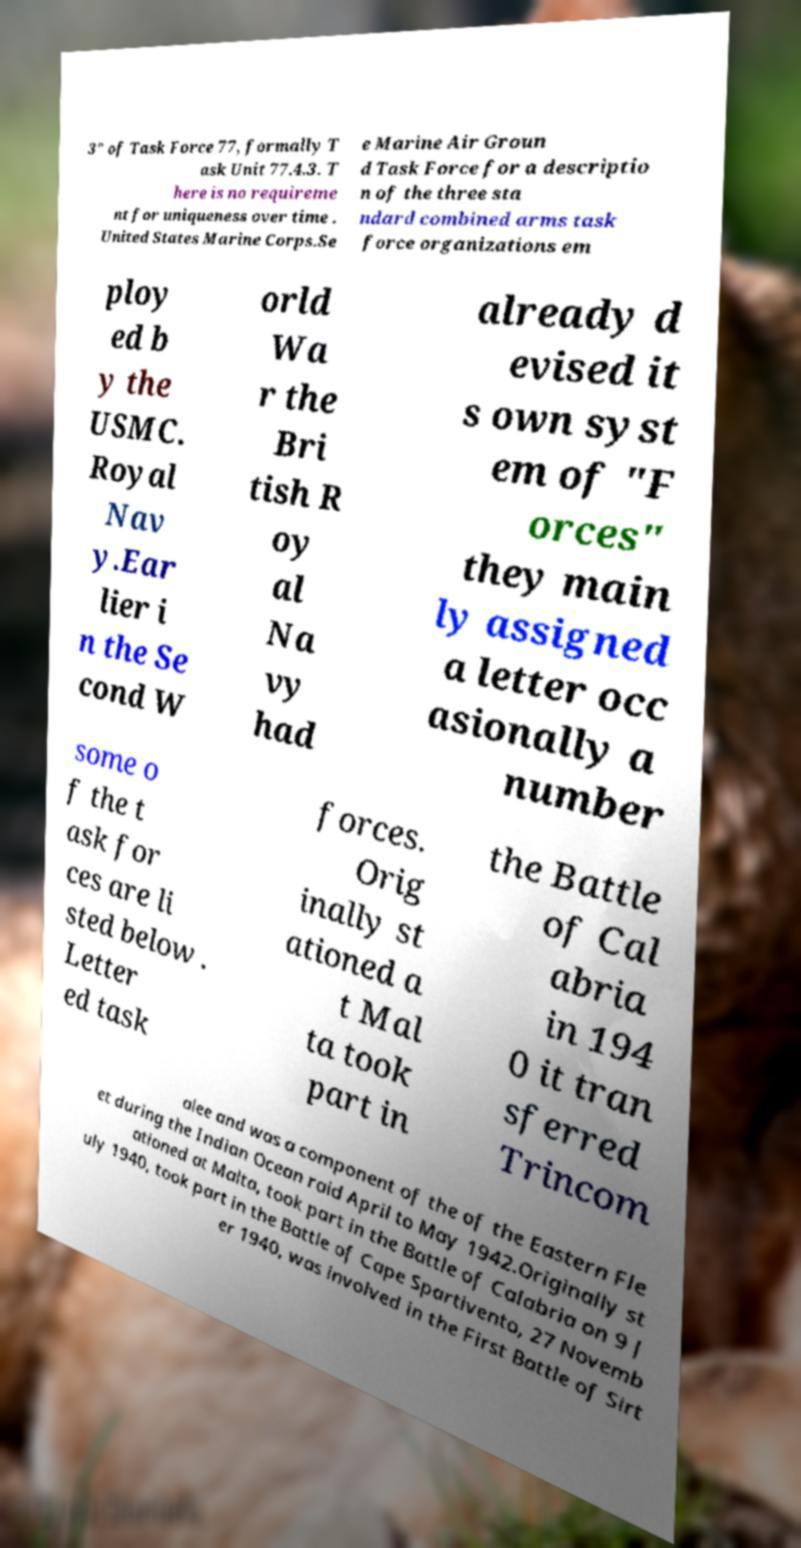Please identify and transcribe the text found in this image. 3" of Task Force 77, formally T ask Unit 77.4.3. T here is no requireme nt for uniqueness over time . United States Marine Corps.Se e Marine Air Groun d Task Force for a descriptio n of the three sta ndard combined arms task force organizations em ploy ed b y the USMC. Royal Nav y.Ear lier i n the Se cond W orld Wa r the Bri tish R oy al Na vy had already d evised it s own syst em of "F orces" they main ly assigned a letter occ asionally a number some o f the t ask for ces are li sted below . Letter ed task forces. Orig inally st ationed a t Mal ta took part in the Battle of Cal abria in 194 0 it tran sferred Trincom alee and was a component of the of the Eastern Fle et during the Indian Ocean raid April to May 1942.Originally st ationed at Malta, took part in the Battle of Calabria on 9 J uly 1940, took part in the Battle of Cape Spartivento, 27 Novemb er 1940, was involved in the First Battle of Sirt 